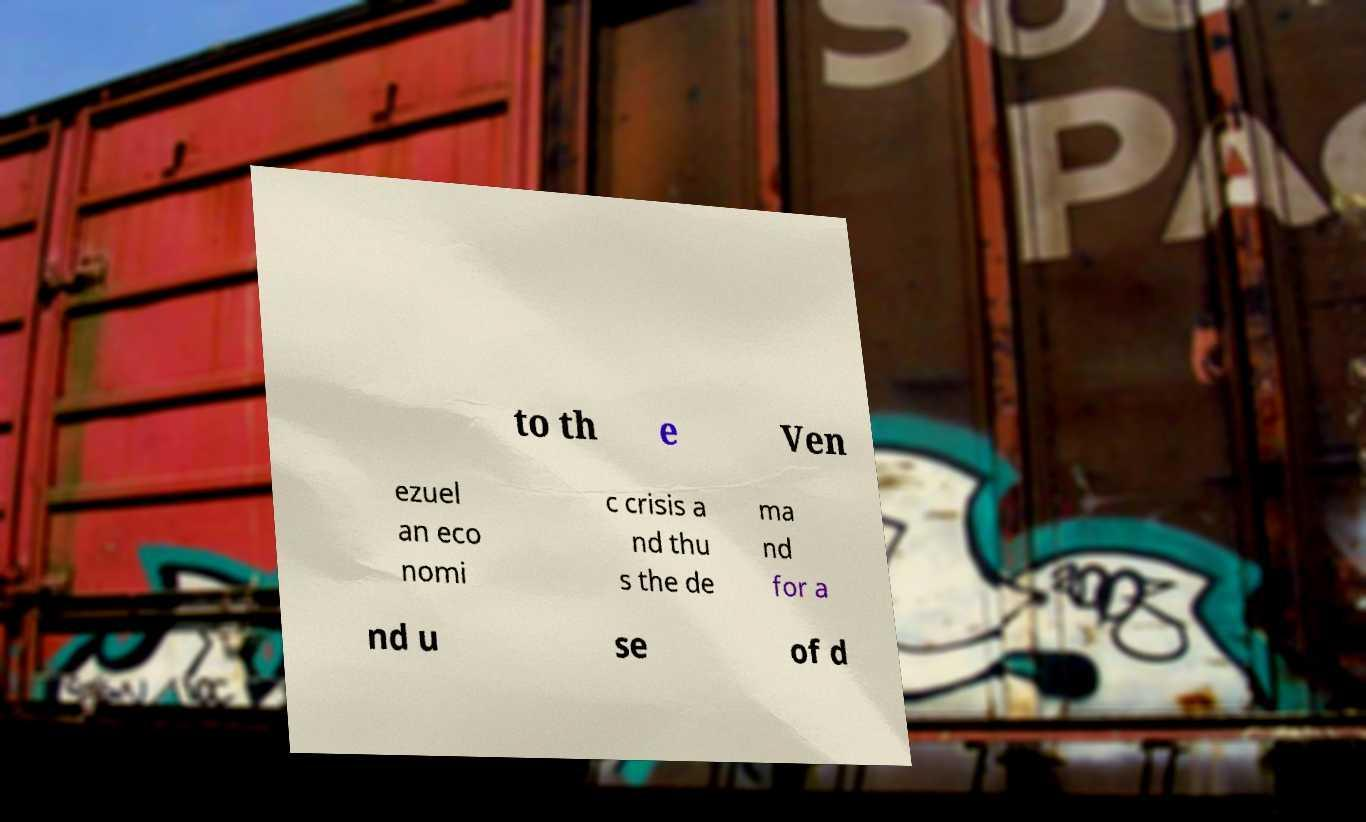Can you accurately transcribe the text from the provided image for me? to th e Ven ezuel an eco nomi c crisis a nd thu s the de ma nd for a nd u se of d 